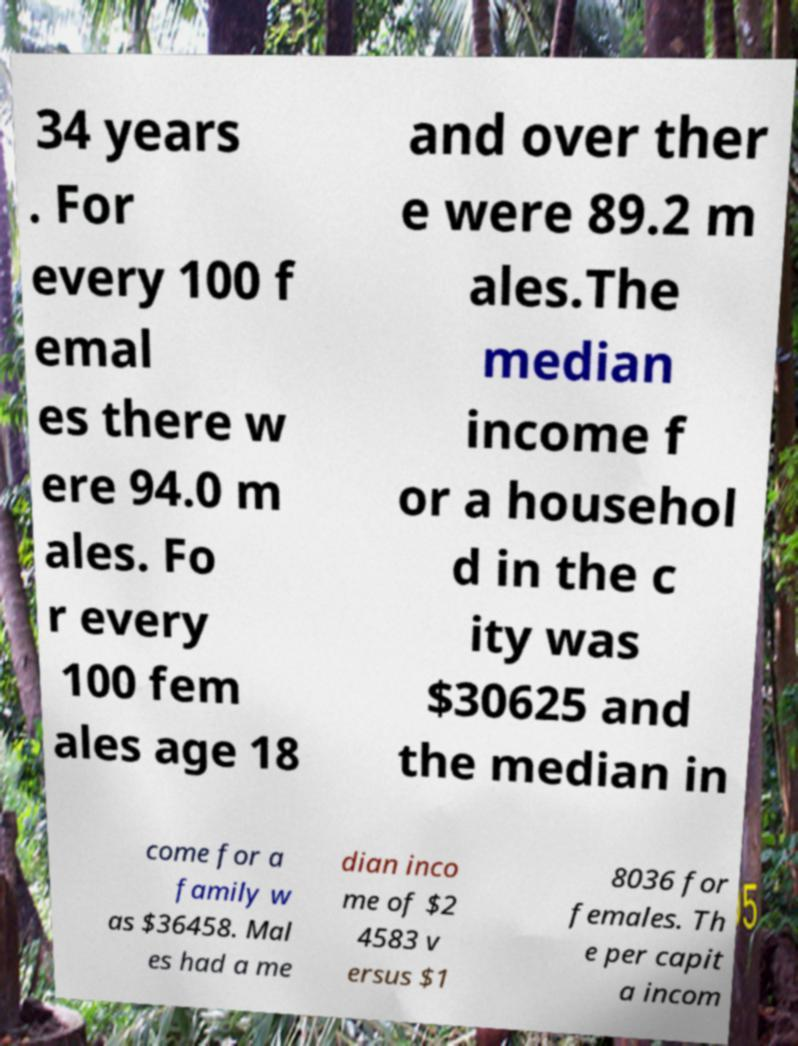Please identify and transcribe the text found in this image. 34 years . For every 100 f emal es there w ere 94.0 m ales. Fo r every 100 fem ales age 18 and over ther e were 89.2 m ales.The median income f or a househol d in the c ity was $30625 and the median in come for a family w as $36458. Mal es had a me dian inco me of $2 4583 v ersus $1 8036 for females. Th e per capit a incom 